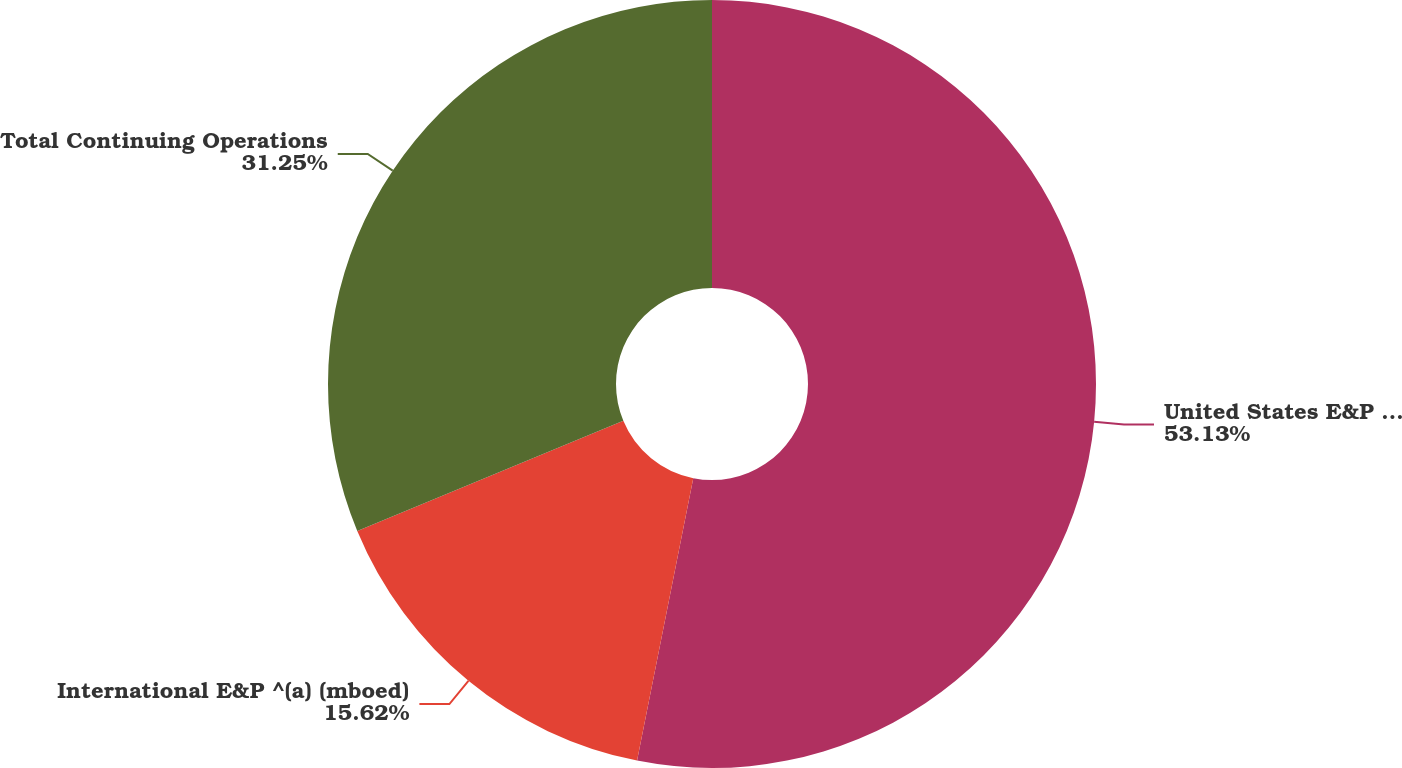<chart> <loc_0><loc_0><loc_500><loc_500><pie_chart><fcel>United States E&P (mboed)<fcel>International E&P ^(a) (mboed)<fcel>Total Continuing Operations<nl><fcel>53.12%<fcel>15.62%<fcel>31.25%<nl></chart> 